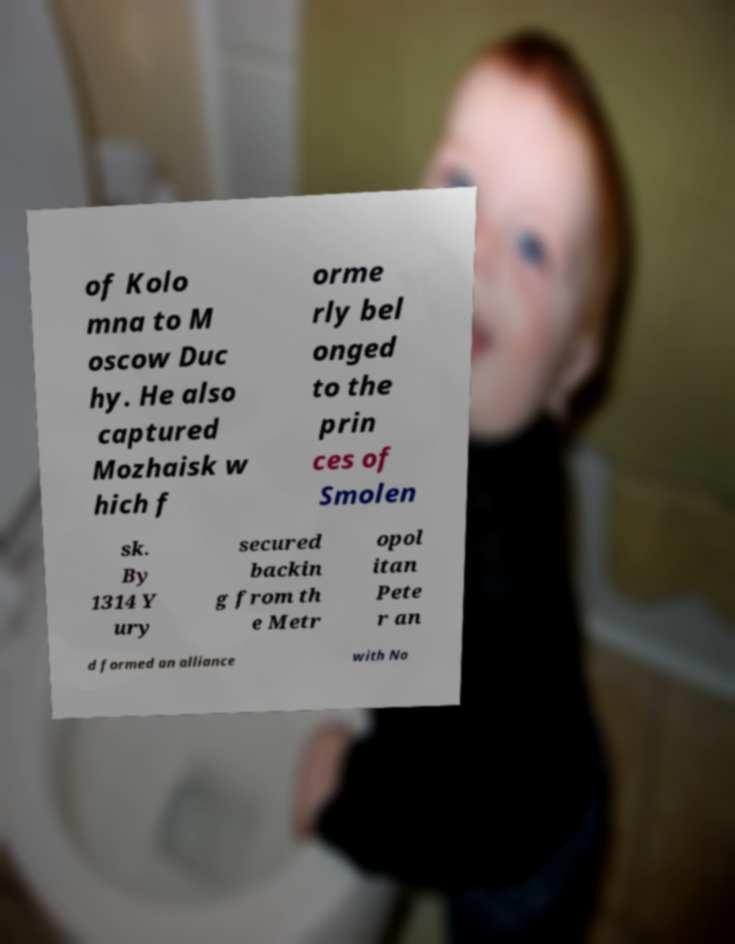I need the written content from this picture converted into text. Can you do that? of Kolo mna to M oscow Duc hy. He also captured Mozhaisk w hich f orme rly bel onged to the prin ces of Smolen sk. By 1314 Y ury secured backin g from th e Metr opol itan Pete r an d formed an alliance with No 